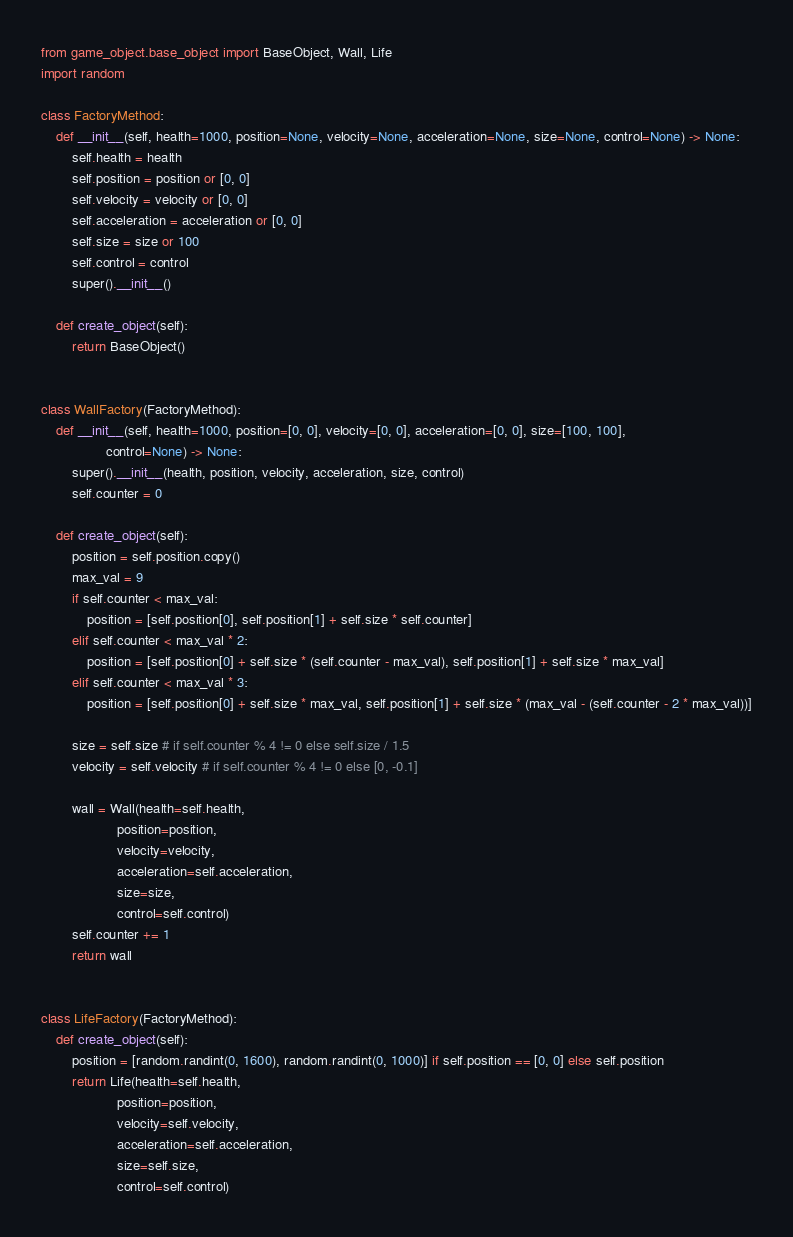<code> <loc_0><loc_0><loc_500><loc_500><_Python_>from game_object.base_object import BaseObject, Wall, Life
import random

class FactoryMethod:
    def __init__(self, health=1000, position=None, velocity=None, acceleration=None, size=None, control=None) -> None:
        self.health = health
        self.position = position or [0, 0]
        self.velocity = velocity or [0, 0]
        self.acceleration = acceleration or [0, 0]
        self.size = size or 100
        self.control = control
        super().__init__()

    def create_object(self):
        return BaseObject()


class WallFactory(FactoryMethod):
    def __init__(self, health=1000, position=[0, 0], velocity=[0, 0], acceleration=[0, 0], size=[100, 100],
                 control=None) -> None:
        super().__init__(health, position, velocity, acceleration, size, control)
        self.counter = 0

    def create_object(self):
        position = self.position.copy()
        max_val = 9
        if self.counter < max_val:
            position = [self.position[0], self.position[1] + self.size * self.counter]
        elif self.counter < max_val * 2:
            position = [self.position[0] + self.size * (self.counter - max_val), self.position[1] + self.size * max_val]
        elif self.counter < max_val * 3:
            position = [self.position[0] + self.size * max_val, self.position[1] + self.size * (max_val - (self.counter - 2 * max_val))]

        size = self.size # if self.counter % 4 != 0 else self.size / 1.5
        velocity = self.velocity # if self.counter % 4 != 0 else [0, -0.1]

        wall = Wall(health=self.health,
                    position=position,
                    velocity=velocity,
                    acceleration=self.acceleration,
                    size=size,
                    control=self.control)
        self.counter += 1
        return wall


class LifeFactory(FactoryMethod):
    def create_object(self):
        position = [random.randint(0, 1600), random.randint(0, 1000)] if self.position == [0, 0] else self.position
        return Life(health=self.health,
                    position=position,
                    velocity=self.velocity,
                    acceleration=self.acceleration,
                    size=self.size,
                    control=self.control)
</code> 